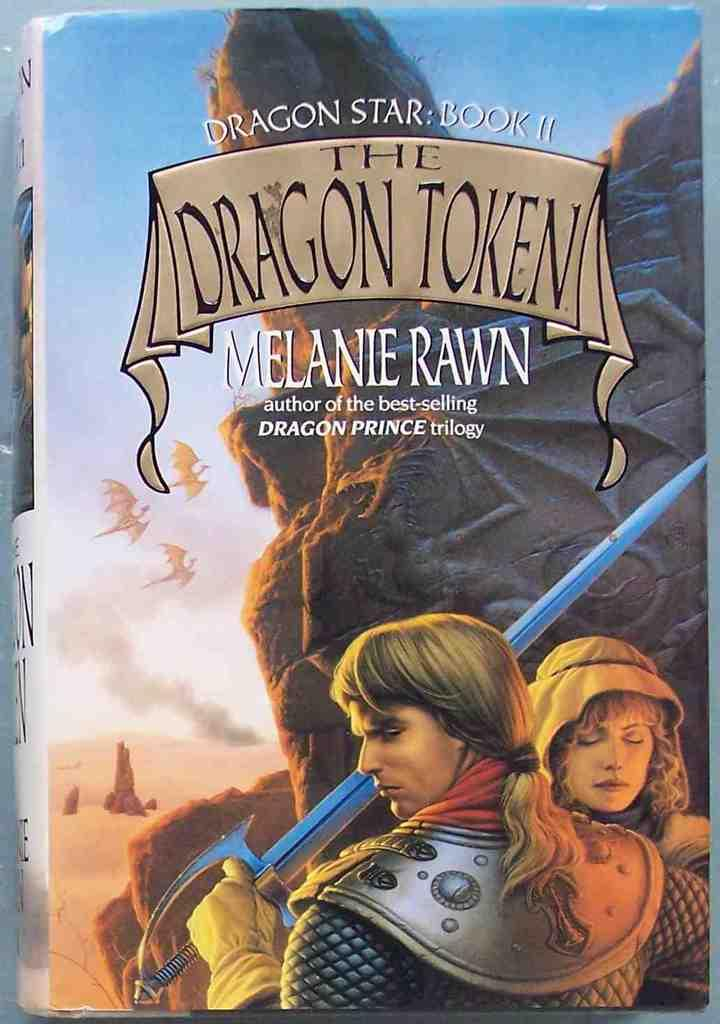What is the main subject of the image? The main subject of the image is a cover page of a book. What can be seen on the cover page? There is text on the cover page. Are there any people in the image? Yes, there is a woman and a man in the image. What is the man holding in the image? The man is holding a sword. Can you describe the wall that the book is leaning against in the image? There is no wall present in the image; the book is not leaning against any wall. 